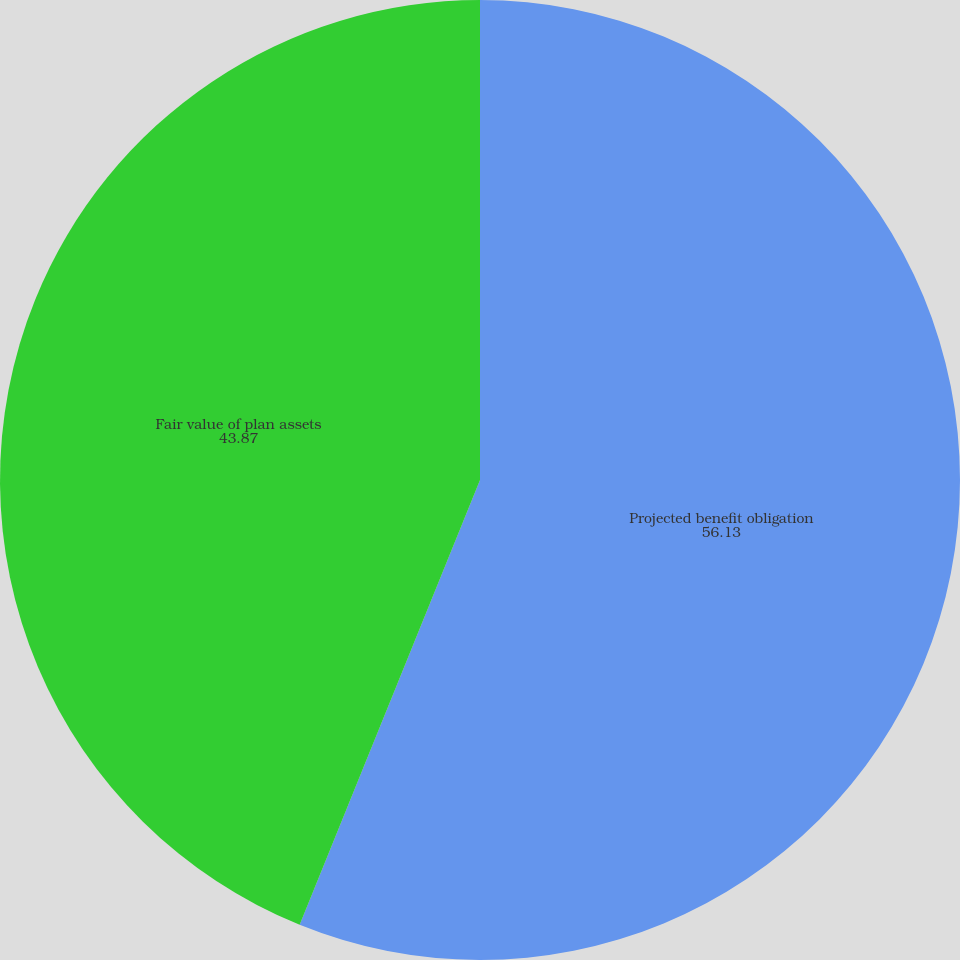Convert chart. <chart><loc_0><loc_0><loc_500><loc_500><pie_chart><fcel>Projected benefit obligation<fcel>Fair value of plan assets<nl><fcel>56.13%<fcel>43.87%<nl></chart> 